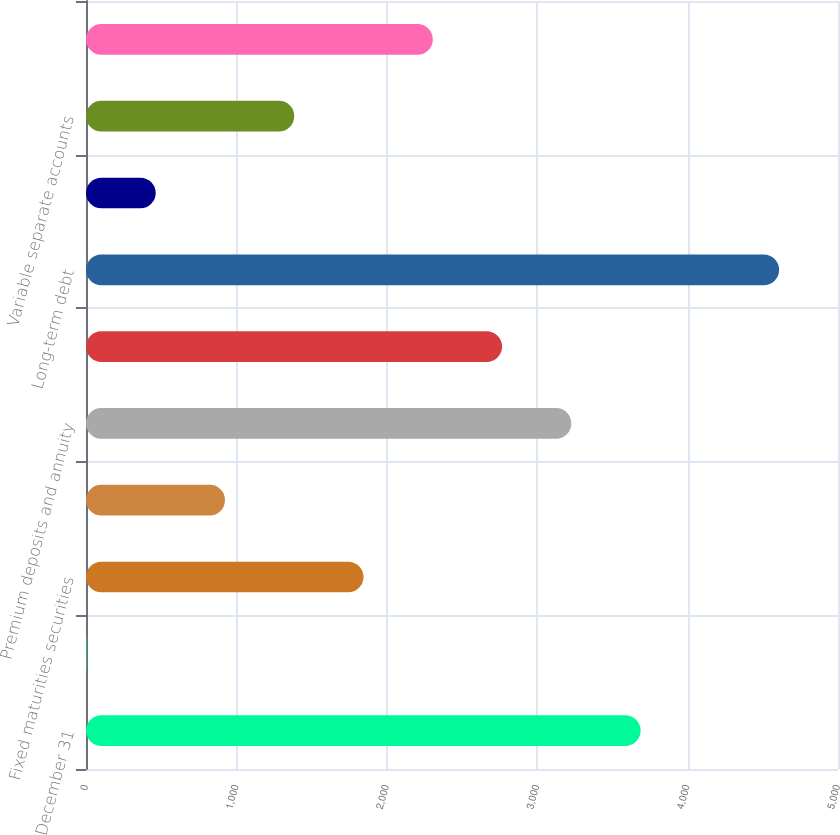Convert chart to OTSL. <chart><loc_0><loc_0><loc_500><loc_500><bar_chart><fcel>December 31<fcel>Other investments<fcel>Fixed maturities securities<fcel>Equity securities<fcel>Premium deposits and annuity<fcel>Short-term debt<fcel>Long-term debt<fcel>Financial guarantee contracts<fcel>Variable separate accounts<fcel>Other<nl><fcel>3687.48<fcel>3<fcel>1845.24<fcel>924.12<fcel>3226.92<fcel>2766.36<fcel>4608.6<fcel>463.56<fcel>1384.68<fcel>2305.8<nl></chart> 